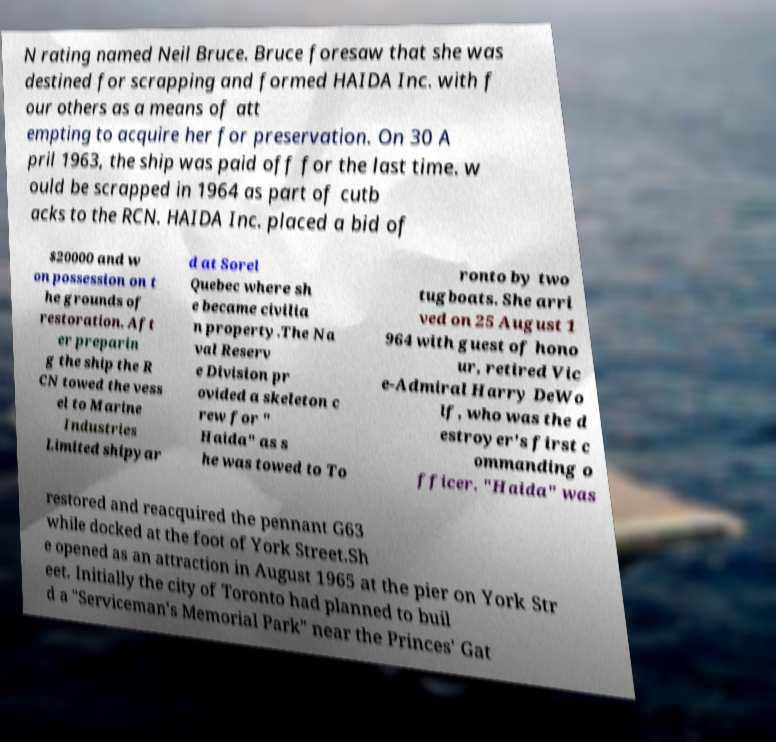For documentation purposes, I need the text within this image transcribed. Could you provide that? N rating named Neil Bruce. Bruce foresaw that she was destined for scrapping and formed HAIDA Inc. with f our others as a means of att empting to acquire her for preservation. On 30 A pril 1963, the ship was paid off for the last time. w ould be scrapped in 1964 as part of cutb acks to the RCN. HAIDA Inc. placed a bid of $20000 and w on possession on t he grounds of restoration. Aft er preparin g the ship the R CN towed the vess el to Marine Industries Limited shipyar d at Sorel Quebec where sh e became civilia n property.The Na val Reserv e Division pr ovided a skeleton c rew for " Haida" as s he was towed to To ronto by two tugboats. She arri ved on 25 August 1 964 with guest of hono ur, retired Vic e-Admiral Harry DeWo lf, who was the d estroyer's first c ommanding o fficer. "Haida" was restored and reacquired the pennant G63 while docked at the foot of York Street.Sh e opened as an attraction in August 1965 at the pier on York Str eet. Initially the city of Toronto had planned to buil d a "Serviceman's Memorial Park" near the Princes' Gat 